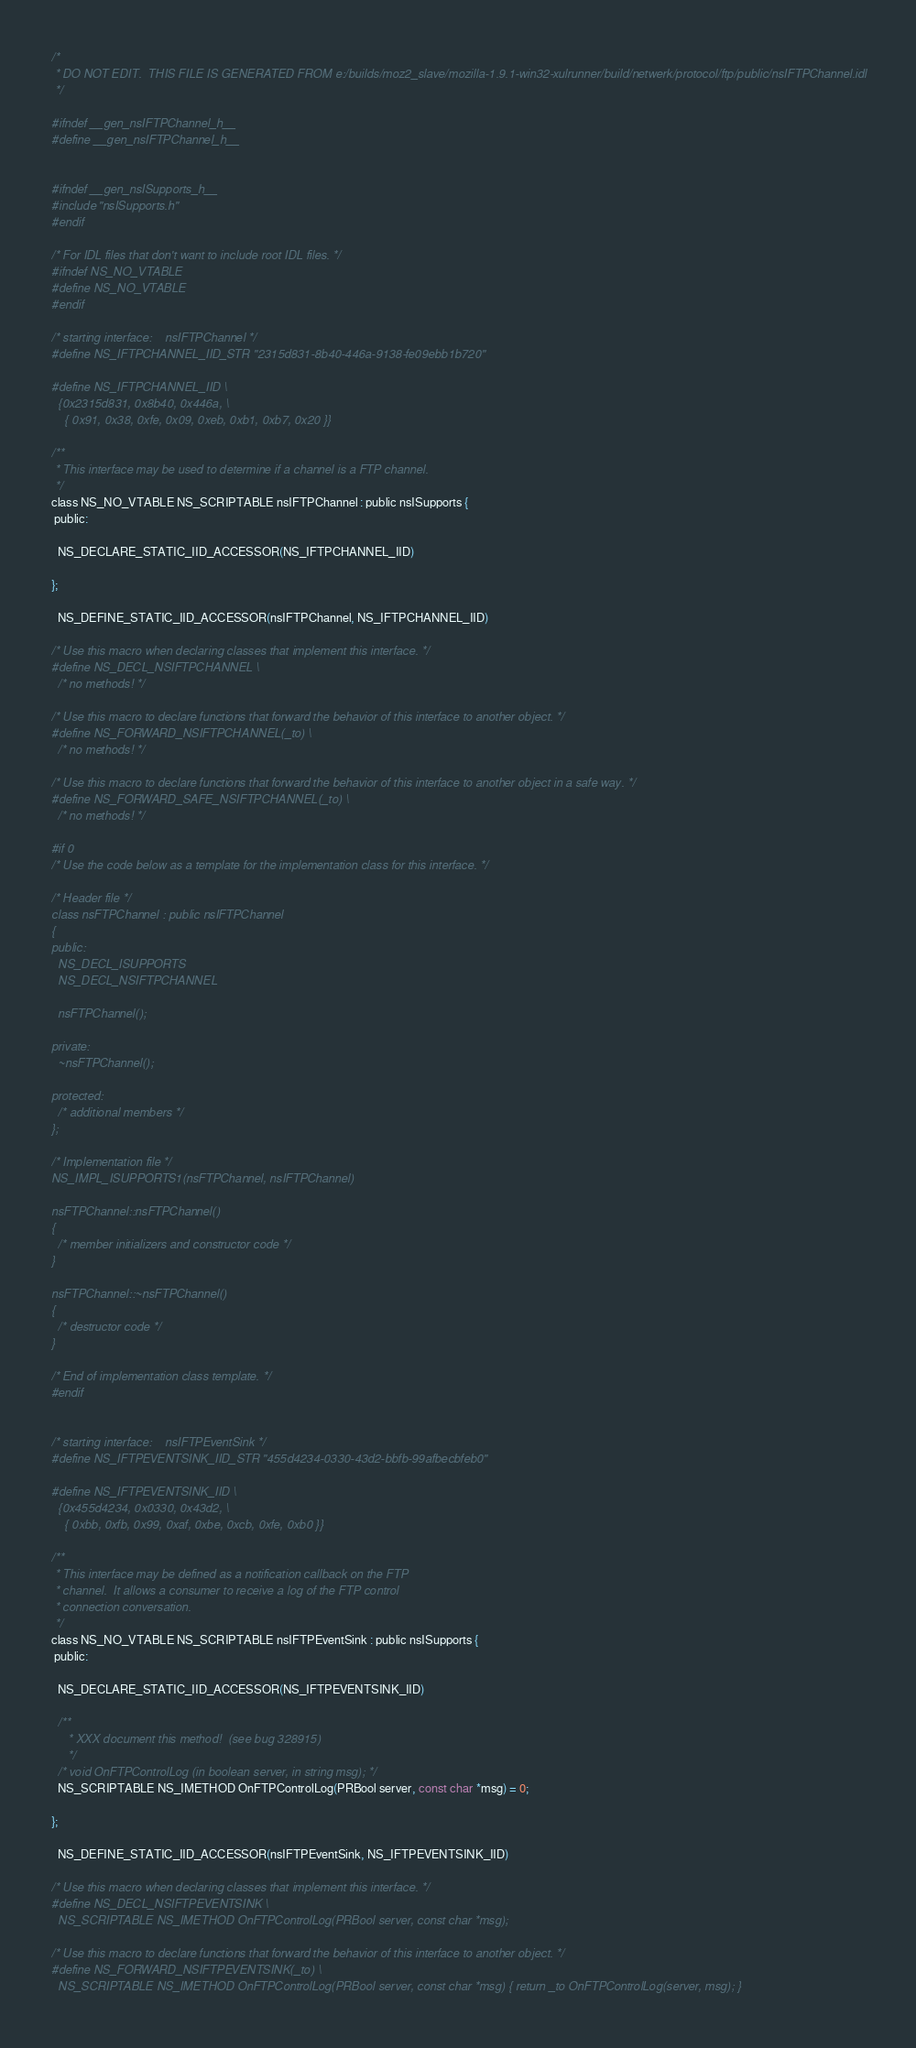<code> <loc_0><loc_0><loc_500><loc_500><_C_>/*
 * DO NOT EDIT.  THIS FILE IS GENERATED FROM e:/builds/moz2_slave/mozilla-1.9.1-win32-xulrunner/build/netwerk/protocol/ftp/public/nsIFTPChannel.idl
 */

#ifndef __gen_nsIFTPChannel_h__
#define __gen_nsIFTPChannel_h__


#ifndef __gen_nsISupports_h__
#include "nsISupports.h"
#endif

/* For IDL files that don't want to include root IDL files. */
#ifndef NS_NO_VTABLE
#define NS_NO_VTABLE
#endif

/* starting interface:    nsIFTPChannel */
#define NS_IFTPCHANNEL_IID_STR "2315d831-8b40-446a-9138-fe09ebb1b720"

#define NS_IFTPCHANNEL_IID \
  {0x2315d831, 0x8b40, 0x446a, \
    { 0x91, 0x38, 0xfe, 0x09, 0xeb, 0xb1, 0xb7, 0x20 }}

/**
 * This interface may be used to determine if a channel is a FTP channel.
 */
class NS_NO_VTABLE NS_SCRIPTABLE nsIFTPChannel : public nsISupports {
 public: 

  NS_DECLARE_STATIC_IID_ACCESSOR(NS_IFTPCHANNEL_IID)

};

  NS_DEFINE_STATIC_IID_ACCESSOR(nsIFTPChannel, NS_IFTPCHANNEL_IID)

/* Use this macro when declaring classes that implement this interface. */
#define NS_DECL_NSIFTPCHANNEL \
  /* no methods! */

/* Use this macro to declare functions that forward the behavior of this interface to another object. */
#define NS_FORWARD_NSIFTPCHANNEL(_to) \
  /* no methods! */

/* Use this macro to declare functions that forward the behavior of this interface to another object in a safe way. */
#define NS_FORWARD_SAFE_NSIFTPCHANNEL(_to) \
  /* no methods! */

#if 0
/* Use the code below as a template for the implementation class for this interface. */

/* Header file */
class nsFTPChannel : public nsIFTPChannel
{
public:
  NS_DECL_ISUPPORTS
  NS_DECL_NSIFTPCHANNEL

  nsFTPChannel();

private:
  ~nsFTPChannel();

protected:
  /* additional members */
};

/* Implementation file */
NS_IMPL_ISUPPORTS1(nsFTPChannel, nsIFTPChannel)

nsFTPChannel::nsFTPChannel()
{
  /* member initializers and constructor code */
}

nsFTPChannel::~nsFTPChannel()
{
  /* destructor code */
}

/* End of implementation class template. */
#endif


/* starting interface:    nsIFTPEventSink */
#define NS_IFTPEVENTSINK_IID_STR "455d4234-0330-43d2-bbfb-99afbecbfeb0"

#define NS_IFTPEVENTSINK_IID \
  {0x455d4234, 0x0330, 0x43d2, \
    { 0xbb, 0xfb, 0x99, 0xaf, 0xbe, 0xcb, 0xfe, 0xb0 }}

/**
 * This interface may be defined as a notification callback on the FTP
 * channel.  It allows a consumer to receive a log of the FTP control
 * connection conversation.
 */
class NS_NO_VTABLE NS_SCRIPTABLE nsIFTPEventSink : public nsISupports {
 public: 

  NS_DECLARE_STATIC_IID_ACCESSOR(NS_IFTPEVENTSINK_IID)

  /**
     * XXX document this method!  (see bug 328915)
     */
  /* void OnFTPControlLog (in boolean server, in string msg); */
  NS_SCRIPTABLE NS_IMETHOD OnFTPControlLog(PRBool server, const char *msg) = 0;

};

  NS_DEFINE_STATIC_IID_ACCESSOR(nsIFTPEventSink, NS_IFTPEVENTSINK_IID)

/* Use this macro when declaring classes that implement this interface. */
#define NS_DECL_NSIFTPEVENTSINK \
  NS_SCRIPTABLE NS_IMETHOD OnFTPControlLog(PRBool server, const char *msg); 

/* Use this macro to declare functions that forward the behavior of this interface to another object. */
#define NS_FORWARD_NSIFTPEVENTSINK(_to) \
  NS_SCRIPTABLE NS_IMETHOD OnFTPControlLog(PRBool server, const char *msg) { return _to OnFTPControlLog(server, msg); } 
</code> 